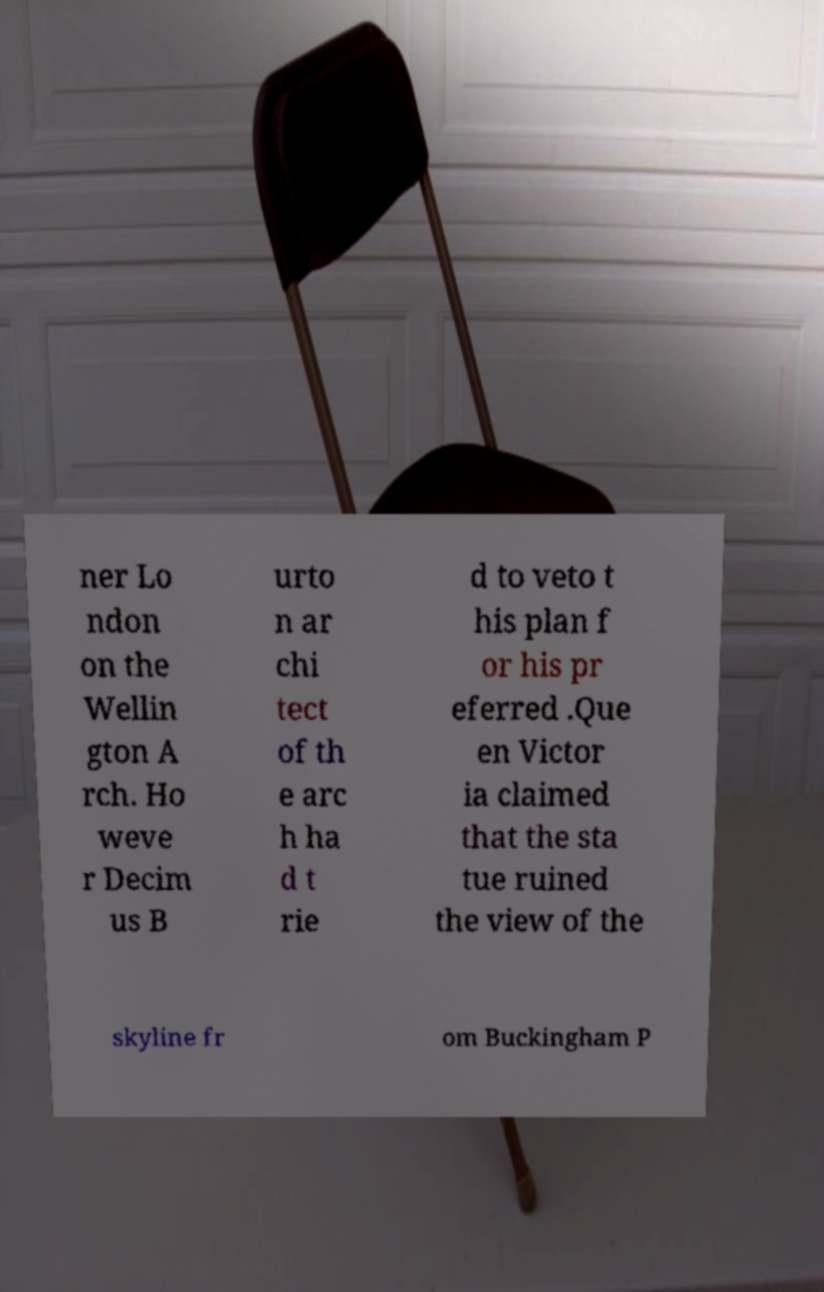Could you extract and type out the text from this image? ner Lo ndon on the Wellin gton A rch. Ho weve r Decim us B urto n ar chi tect of th e arc h ha d t rie d to veto t his plan f or his pr eferred .Que en Victor ia claimed that the sta tue ruined the view of the skyline fr om Buckingham P 